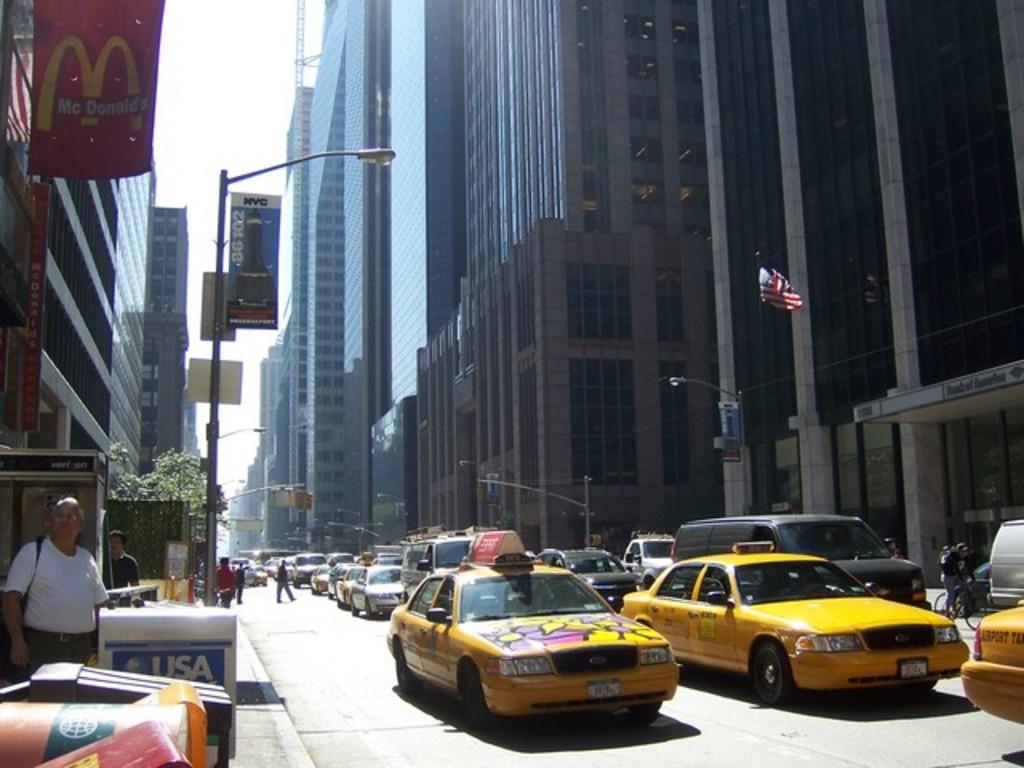What company is on the red flag in the left corner?
Give a very brief answer. Mcdonalds. What 3 letters are written in white on the news paper rack?
Your answer should be very brief. Usa. 